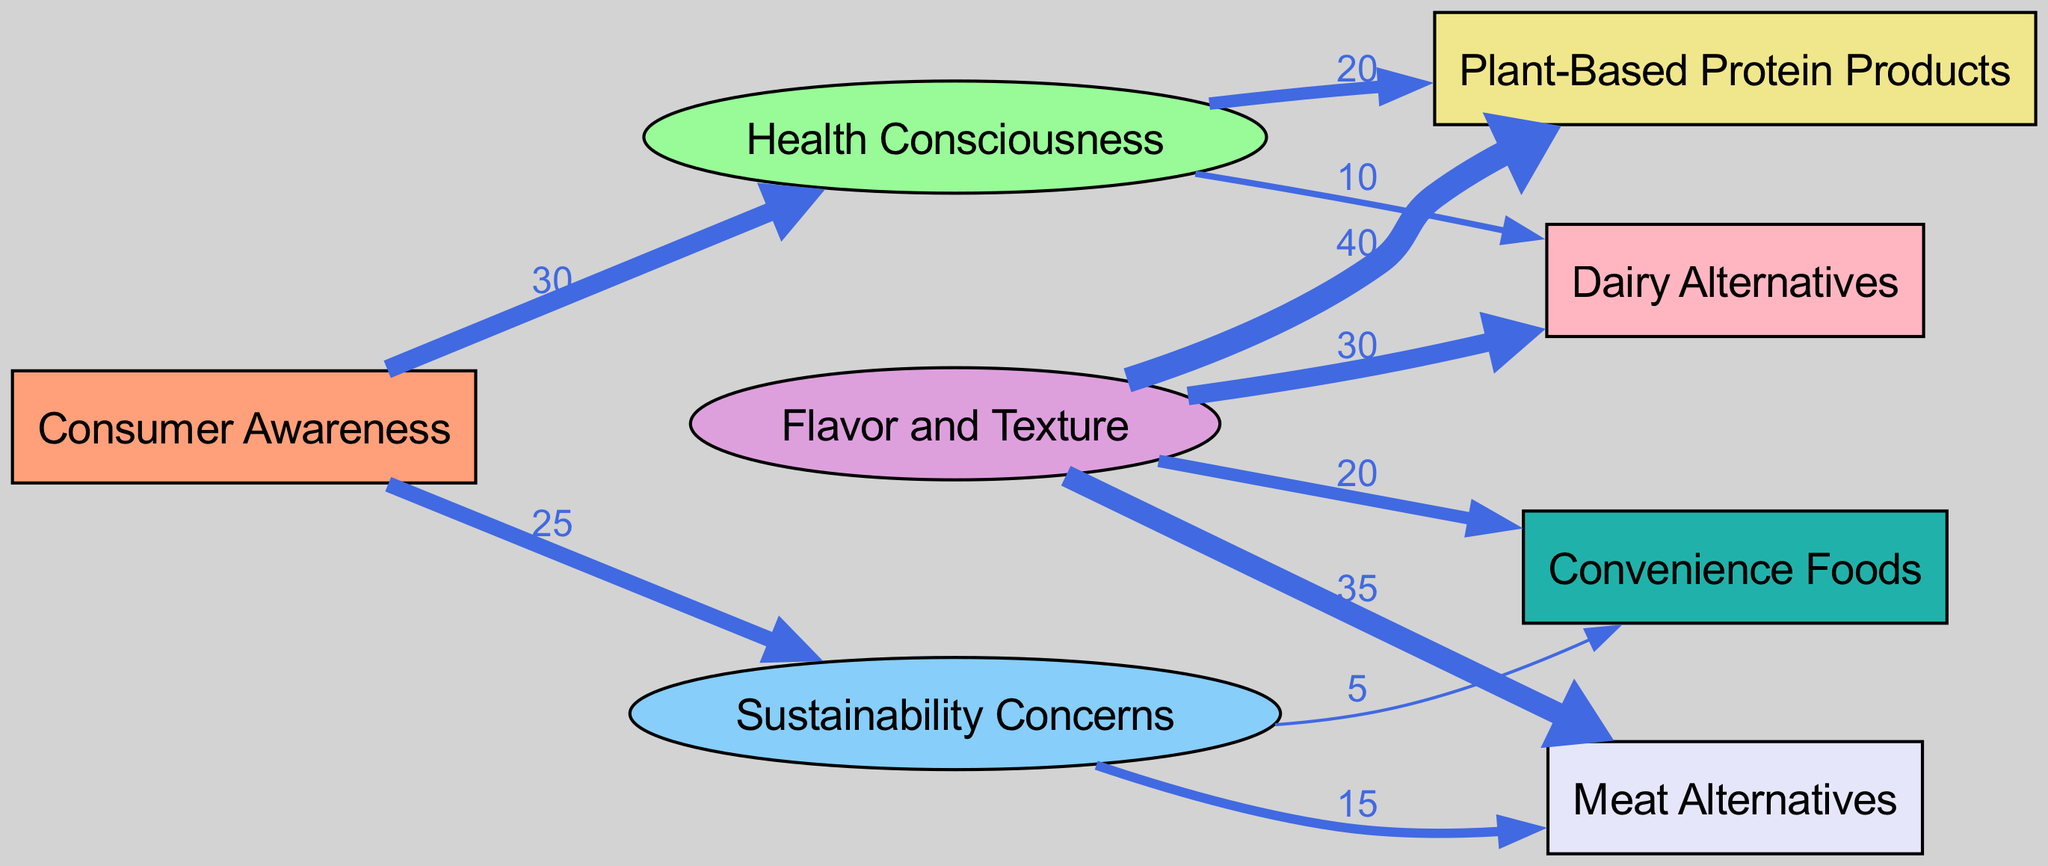What is the total number of nodes in the diagram? The diagram includes the following nodes: 'Consumer Awareness', 'Health Consciousness', 'Sustainability Concerns', 'Flavor and Texture', 'Plant-Based Protein Products', 'Meat Alternatives', 'Dairy Alternatives', and 'Convenience Foods'. Counting all, there are 8 nodes.
Answer: 8 Which node has the highest flow value directed towards 'Plant-Based Protein Products'? The 'Flavor and Texture' node has a flow value of 40 directed towards 'Plant-Based Protein Products', which is higher compared to other nodes. No other node directs flow to this product with a higher value.
Answer: 40 What is the flow value from 'Consumer Awareness' to 'Sustainability Concerns'? The 'Consumer Awareness' node directs a flow of 25 towards the 'Sustainability Concerns' node. This value is labeled on the edge connecting these two nodes in the diagram.
Answer: 25 Which market segment receives the least focus based on this diagram? The 'Convenience Foods' segment has the least flow value directed towards it from the 'Sustainability Concerns' node, with a flow value of 5, indicating the least consumer preference compared to others.
Answer: Convenience Foods How does 'Health Consciousness' influence the 'Dairy Alternatives' segment? 'Health Consciousness' directs a flow of 10 to 'Dairy Alternatives', indicating that as consumers become more health conscious, they also show preference for dairy alternatives. This interplay shows a moderate influence.
Answer: 10 Which two nodes contribute to the highest demand for 'Meat Alternatives'? The nodes 'Flavor and Texture' and 'Sustainability Concerns' are the two contributors, with values of 35 and 15, respectively, resulting in a total demand flow of 50 towards 'Meat Alternatives'.
Answer: 50 What percentage of the total flow value from 'Flavor and Texture' goes to 'Plant-Based Protein Products'? The total flow value from 'Flavor and Texture' to its target nodes is 125 (40 + 35 + 30 + 20). The flow to 'Plant-Based Protein Products' is 40. Thus, (40/125) * 100 = 32%.
Answer: 32% Which nodes act as sources in this diagram? The sources in this diagram are 'Consumer Awareness', which is the only source node that directs its flow to 'Health Consciousness' and 'Sustainability Concerns'. Thus, there is one source node.
Answer: Consumer Awareness Which sink segment has the lowest incoming flow value? Among the sink segments, 'Convenience Foods' receives the least incoming flow value, at 5 from 'Sustainability Concerns', while other segments have higher values.
Answer: Convenience Foods 